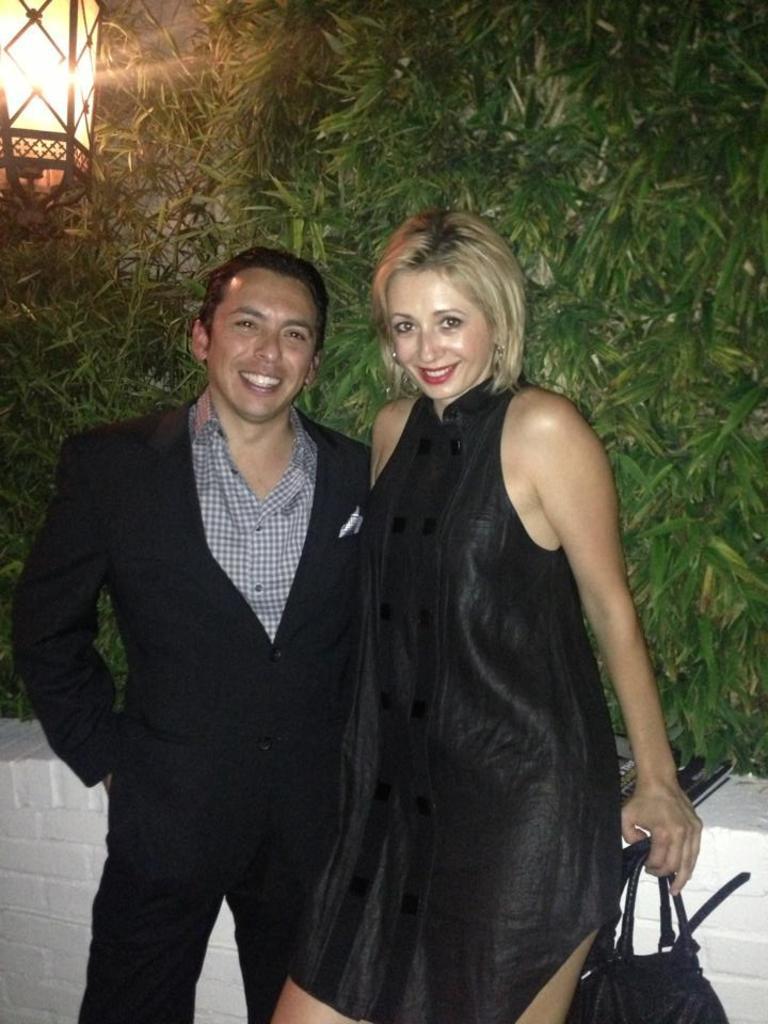Describe this image in one or two sentences. This 2 persons are highlighted in this picture. This woman wore black dress and this man wore black suit. Backside of this person there are plants and light. This woman is holding a bag. 